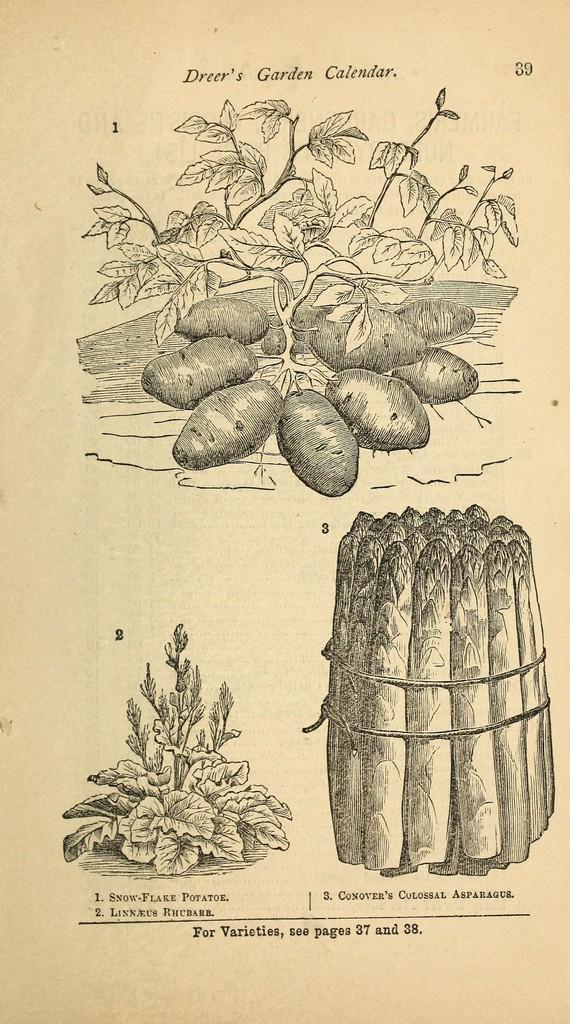Can you describe this image briefly? In this picture we can see arts in the paper. 